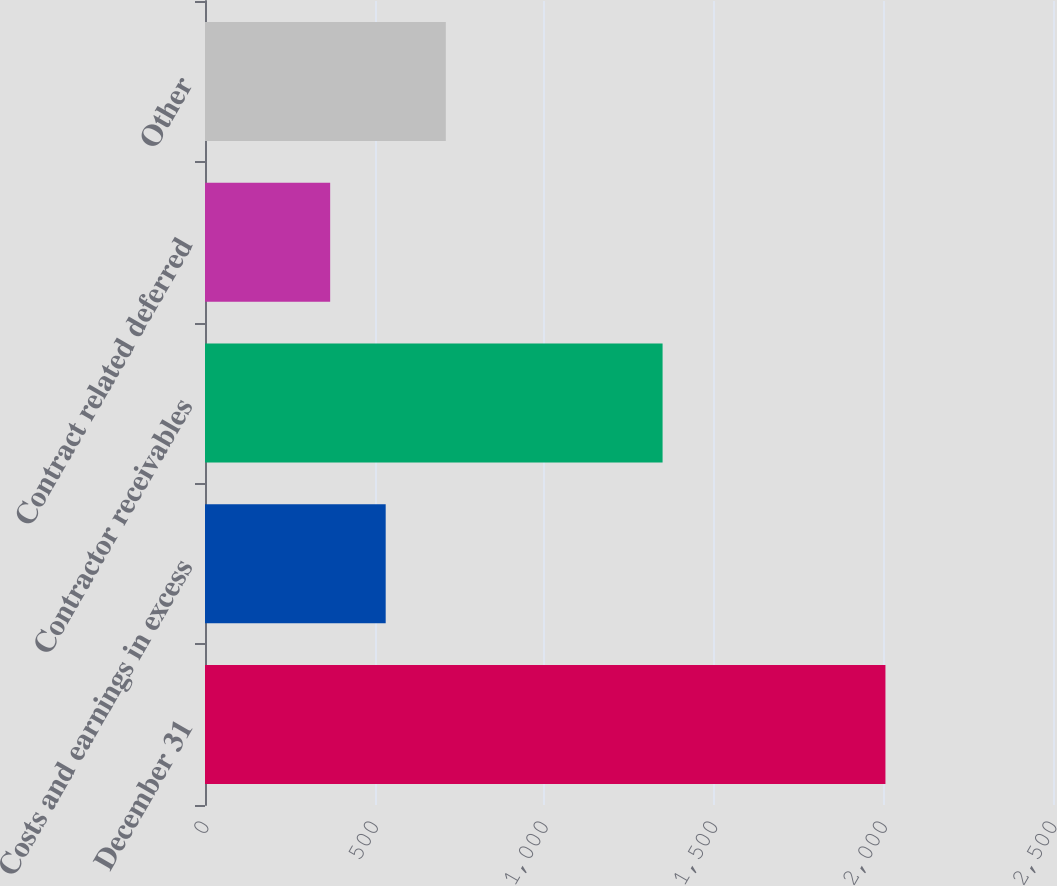<chart> <loc_0><loc_0><loc_500><loc_500><bar_chart><fcel>December 31<fcel>Costs and earnings in excess<fcel>Contractor receivables<fcel>Contract related deferred<fcel>Other<nl><fcel>2006<fcel>532.7<fcel>1349<fcel>369<fcel>710<nl></chart> 